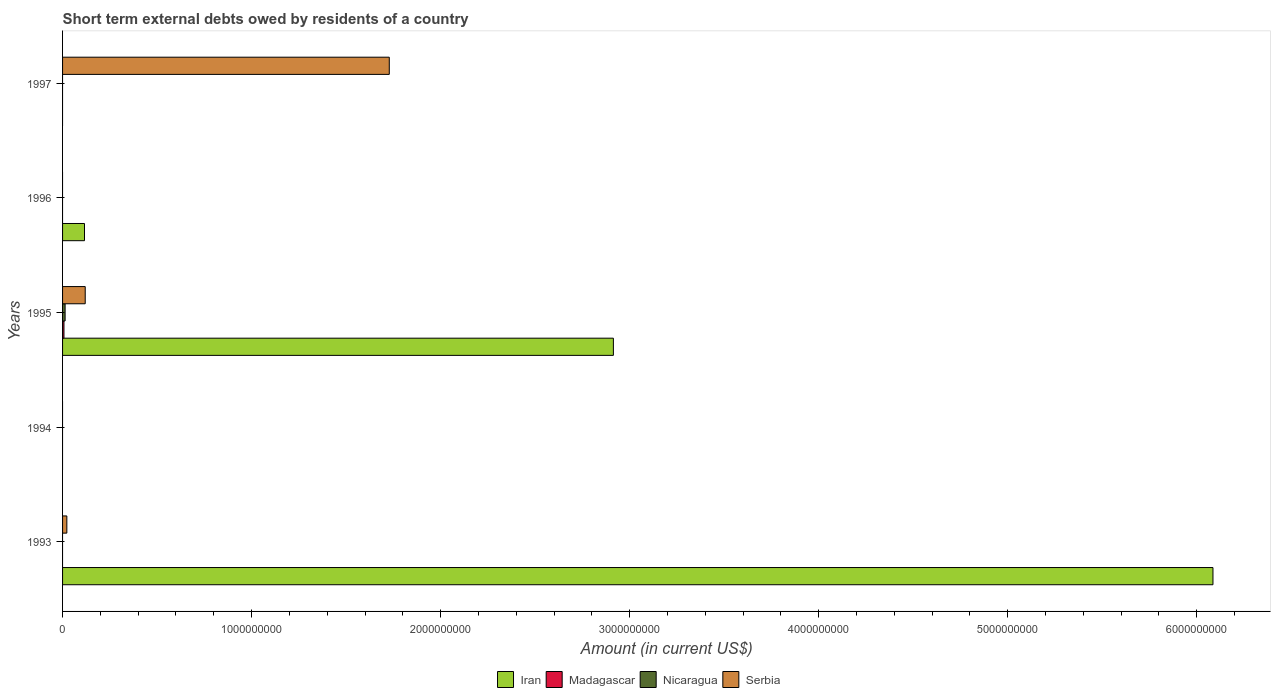Are the number of bars per tick equal to the number of legend labels?
Your response must be concise. No. How many bars are there on the 2nd tick from the top?
Give a very brief answer. 1. How many bars are there on the 1st tick from the bottom?
Your answer should be compact. 2. Across all years, what is the maximum amount of short-term external debts owed by residents in Serbia?
Give a very brief answer. 1.73e+09. What is the total amount of short-term external debts owed by residents in Nicaragua in the graph?
Give a very brief answer. 1.35e+07. What is the difference between the amount of short-term external debts owed by residents in Serbia in 1995 and that in 1997?
Provide a short and direct response. -1.61e+09. What is the difference between the amount of short-term external debts owed by residents in Serbia in 1997 and the amount of short-term external debts owed by residents in Madagascar in 1995?
Make the answer very short. 1.72e+09. What is the average amount of short-term external debts owed by residents in Nicaragua per year?
Provide a short and direct response. 2.69e+06. In the year 1995, what is the difference between the amount of short-term external debts owed by residents in Iran and amount of short-term external debts owed by residents in Nicaragua?
Your answer should be compact. 2.90e+09. In how many years, is the amount of short-term external debts owed by residents in Nicaragua greater than 4800000000 US$?
Ensure brevity in your answer.  0. What is the ratio of the amount of short-term external debts owed by residents in Iran in 1995 to that in 1996?
Your response must be concise. 25.12. What is the difference between the highest and the second highest amount of short-term external debts owed by residents in Serbia?
Provide a succinct answer. 1.61e+09. What is the difference between the highest and the lowest amount of short-term external debts owed by residents in Iran?
Your response must be concise. 6.09e+09. Is it the case that in every year, the sum of the amount of short-term external debts owed by residents in Iran and amount of short-term external debts owed by residents in Madagascar is greater than the sum of amount of short-term external debts owed by residents in Serbia and amount of short-term external debts owed by residents in Nicaragua?
Your response must be concise. No. Are all the bars in the graph horizontal?
Ensure brevity in your answer.  Yes. How many years are there in the graph?
Ensure brevity in your answer.  5. Are the values on the major ticks of X-axis written in scientific E-notation?
Your response must be concise. No. Does the graph contain any zero values?
Your response must be concise. Yes. How many legend labels are there?
Offer a very short reply. 4. How are the legend labels stacked?
Ensure brevity in your answer.  Horizontal. What is the title of the graph?
Make the answer very short. Short term external debts owed by residents of a country. What is the label or title of the X-axis?
Your answer should be compact. Amount (in current US$). What is the Amount (in current US$) of Iran in 1993?
Offer a terse response. 6.09e+09. What is the Amount (in current US$) in Nicaragua in 1993?
Give a very brief answer. 0. What is the Amount (in current US$) of Serbia in 1993?
Your response must be concise. 2.26e+07. What is the Amount (in current US$) in Madagascar in 1994?
Make the answer very short. 0. What is the Amount (in current US$) of Serbia in 1994?
Your answer should be very brief. 0. What is the Amount (in current US$) of Iran in 1995?
Your answer should be very brief. 2.91e+09. What is the Amount (in current US$) in Madagascar in 1995?
Provide a succinct answer. 7.42e+06. What is the Amount (in current US$) of Nicaragua in 1995?
Ensure brevity in your answer.  1.35e+07. What is the Amount (in current US$) of Serbia in 1995?
Your answer should be compact. 1.20e+08. What is the Amount (in current US$) of Iran in 1996?
Offer a terse response. 1.16e+08. What is the Amount (in current US$) in Nicaragua in 1996?
Offer a terse response. 0. What is the Amount (in current US$) of Serbia in 1996?
Make the answer very short. 0. What is the Amount (in current US$) of Nicaragua in 1997?
Offer a very short reply. 0. What is the Amount (in current US$) of Serbia in 1997?
Give a very brief answer. 1.73e+09. Across all years, what is the maximum Amount (in current US$) in Iran?
Provide a short and direct response. 6.09e+09. Across all years, what is the maximum Amount (in current US$) in Madagascar?
Offer a very short reply. 7.42e+06. Across all years, what is the maximum Amount (in current US$) of Nicaragua?
Offer a terse response. 1.35e+07. Across all years, what is the maximum Amount (in current US$) in Serbia?
Offer a terse response. 1.73e+09. What is the total Amount (in current US$) in Iran in the graph?
Provide a short and direct response. 9.12e+09. What is the total Amount (in current US$) of Madagascar in the graph?
Give a very brief answer. 7.42e+06. What is the total Amount (in current US$) of Nicaragua in the graph?
Provide a short and direct response. 1.35e+07. What is the total Amount (in current US$) in Serbia in the graph?
Your answer should be compact. 1.87e+09. What is the difference between the Amount (in current US$) of Iran in 1993 and that in 1995?
Offer a terse response. 3.17e+09. What is the difference between the Amount (in current US$) of Serbia in 1993 and that in 1995?
Give a very brief answer. -9.73e+07. What is the difference between the Amount (in current US$) in Iran in 1993 and that in 1996?
Your answer should be compact. 5.97e+09. What is the difference between the Amount (in current US$) in Serbia in 1993 and that in 1997?
Keep it short and to the point. -1.71e+09. What is the difference between the Amount (in current US$) in Iran in 1995 and that in 1996?
Make the answer very short. 2.80e+09. What is the difference between the Amount (in current US$) of Serbia in 1995 and that in 1997?
Ensure brevity in your answer.  -1.61e+09. What is the difference between the Amount (in current US$) of Iran in 1993 and the Amount (in current US$) of Madagascar in 1995?
Your answer should be compact. 6.08e+09. What is the difference between the Amount (in current US$) of Iran in 1993 and the Amount (in current US$) of Nicaragua in 1995?
Give a very brief answer. 6.07e+09. What is the difference between the Amount (in current US$) in Iran in 1993 and the Amount (in current US$) in Serbia in 1995?
Offer a terse response. 5.97e+09. What is the difference between the Amount (in current US$) of Iran in 1993 and the Amount (in current US$) of Serbia in 1997?
Your answer should be compact. 4.36e+09. What is the difference between the Amount (in current US$) of Iran in 1995 and the Amount (in current US$) of Serbia in 1997?
Keep it short and to the point. 1.19e+09. What is the difference between the Amount (in current US$) in Madagascar in 1995 and the Amount (in current US$) in Serbia in 1997?
Ensure brevity in your answer.  -1.72e+09. What is the difference between the Amount (in current US$) of Nicaragua in 1995 and the Amount (in current US$) of Serbia in 1997?
Provide a succinct answer. -1.71e+09. What is the difference between the Amount (in current US$) in Iran in 1996 and the Amount (in current US$) in Serbia in 1997?
Your response must be concise. -1.61e+09. What is the average Amount (in current US$) of Iran per year?
Your answer should be compact. 1.82e+09. What is the average Amount (in current US$) in Madagascar per year?
Offer a very short reply. 1.48e+06. What is the average Amount (in current US$) of Nicaragua per year?
Make the answer very short. 2.69e+06. What is the average Amount (in current US$) in Serbia per year?
Provide a short and direct response. 3.74e+08. In the year 1993, what is the difference between the Amount (in current US$) in Iran and Amount (in current US$) in Serbia?
Provide a succinct answer. 6.06e+09. In the year 1995, what is the difference between the Amount (in current US$) in Iran and Amount (in current US$) in Madagascar?
Provide a succinct answer. 2.91e+09. In the year 1995, what is the difference between the Amount (in current US$) in Iran and Amount (in current US$) in Nicaragua?
Keep it short and to the point. 2.90e+09. In the year 1995, what is the difference between the Amount (in current US$) of Iran and Amount (in current US$) of Serbia?
Provide a short and direct response. 2.79e+09. In the year 1995, what is the difference between the Amount (in current US$) in Madagascar and Amount (in current US$) in Nicaragua?
Provide a succinct answer. -6.05e+06. In the year 1995, what is the difference between the Amount (in current US$) of Madagascar and Amount (in current US$) of Serbia?
Ensure brevity in your answer.  -1.12e+08. In the year 1995, what is the difference between the Amount (in current US$) in Nicaragua and Amount (in current US$) in Serbia?
Keep it short and to the point. -1.06e+08. What is the ratio of the Amount (in current US$) in Iran in 1993 to that in 1995?
Offer a very short reply. 2.09. What is the ratio of the Amount (in current US$) of Serbia in 1993 to that in 1995?
Keep it short and to the point. 0.19. What is the ratio of the Amount (in current US$) in Iran in 1993 to that in 1996?
Provide a short and direct response. 52.47. What is the ratio of the Amount (in current US$) in Serbia in 1993 to that in 1997?
Make the answer very short. 0.01. What is the ratio of the Amount (in current US$) of Iran in 1995 to that in 1996?
Your answer should be compact. 25.12. What is the ratio of the Amount (in current US$) in Serbia in 1995 to that in 1997?
Your response must be concise. 0.07. What is the difference between the highest and the second highest Amount (in current US$) in Iran?
Provide a short and direct response. 3.17e+09. What is the difference between the highest and the second highest Amount (in current US$) of Serbia?
Offer a terse response. 1.61e+09. What is the difference between the highest and the lowest Amount (in current US$) of Iran?
Offer a terse response. 6.09e+09. What is the difference between the highest and the lowest Amount (in current US$) of Madagascar?
Provide a succinct answer. 7.42e+06. What is the difference between the highest and the lowest Amount (in current US$) in Nicaragua?
Ensure brevity in your answer.  1.35e+07. What is the difference between the highest and the lowest Amount (in current US$) of Serbia?
Your answer should be compact. 1.73e+09. 